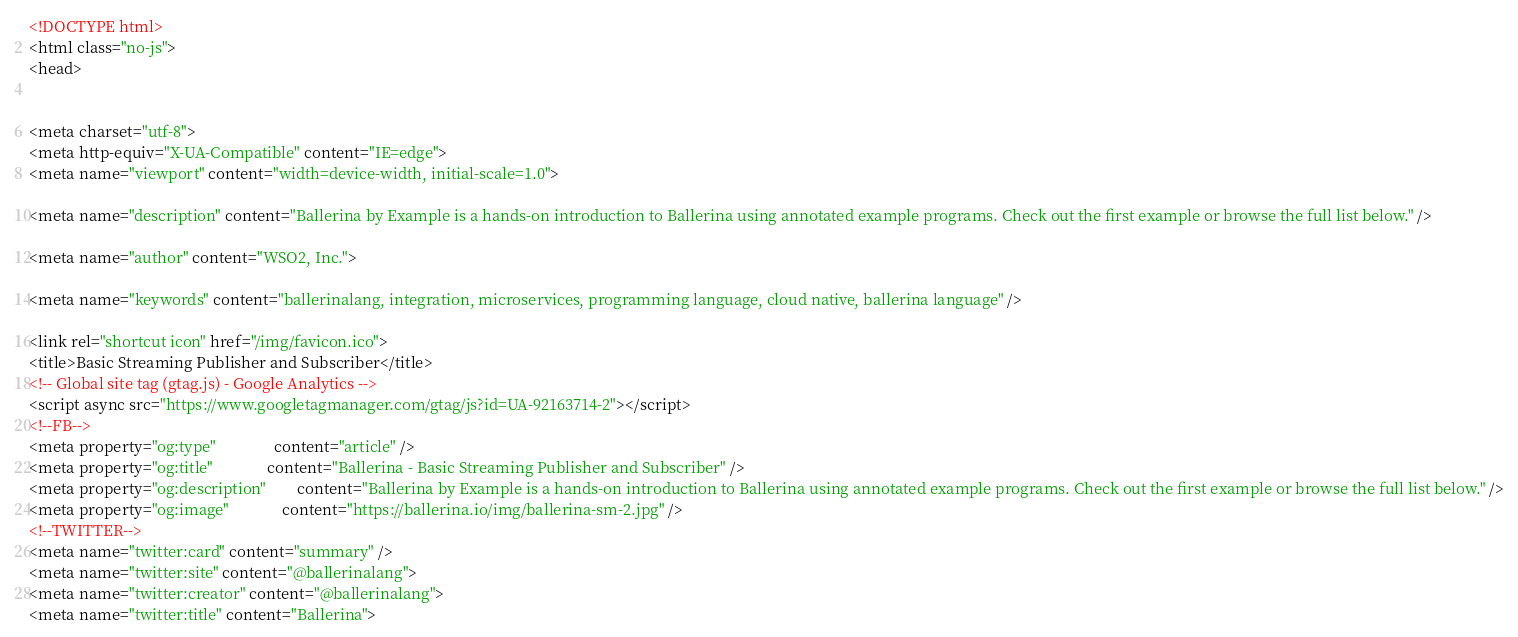<code> <loc_0><loc_0><loc_500><loc_500><_HTML_>

<!DOCTYPE html>
<html class="no-js">
<head>
    

<meta charset="utf-8">
<meta http-equiv="X-UA-Compatible" content="IE=edge">
<meta name="viewport" content="width=device-width, initial-scale=1.0">

<meta name="description" content="Ballerina by Example is a hands-on introduction to Ballerina using annotated example programs. Check out the first example or browse the full list below." />

<meta name="author" content="WSO2, Inc.">

<meta name="keywords" content="ballerinalang, integration, microservices, programming language, cloud native, ballerina language" />

<link rel="shortcut icon" href="/img/favicon.ico">
<title>Basic Streaming Publisher and Subscriber</title>
<!-- Global site tag (gtag.js) - Google Analytics -->
<script async src="https://www.googletagmanager.com/gtag/js?id=UA-92163714-2"></script>
<!--FB-->
<meta property="og:type"               content="article" />
<meta property="og:title"              content="Ballerina - Basic Streaming Publisher and Subscriber" />
<meta property="og:description"        content="Ballerina by Example is a hands-on introduction to Ballerina using annotated example programs. Check out the first example or browse the full list below." />
<meta property="og:image"              content="https://ballerina.io/img/ballerina-sm-2.jpg" />
<!--TWITTER-->
<meta name="twitter:card" content="summary" />
<meta name="twitter:site" content="@ballerinalang">
<meta name="twitter:creator" content="@ballerinalang">
<meta name="twitter:title" content="Ballerina"></code> 